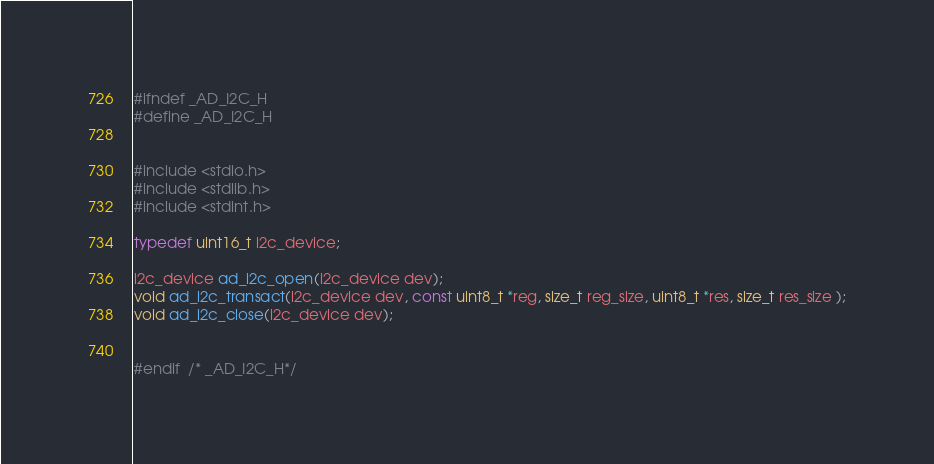Convert code to text. <code><loc_0><loc_0><loc_500><loc_500><_C_>#ifndef _AD_I2C_H
#define _AD_I2C_H


#include <stdio.h>
#include <stdlib.h>
#include <stdint.h>

typedef uint16_t i2c_device;

i2c_device ad_i2c_open(i2c_device dev);
void ad_i2c_transact(i2c_device dev, const uint8_t *reg, size_t reg_size, uint8_t *res, size_t res_size );
void ad_i2c_close(i2c_device dev);


#endif  /* _AD_I2C_H*/
</code> 